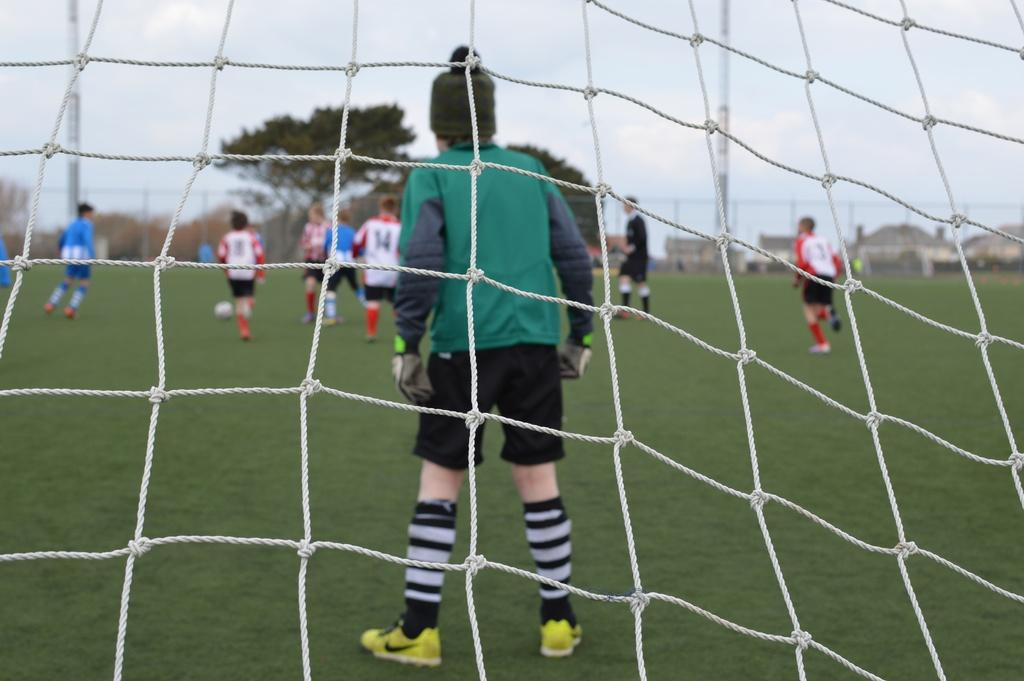<image>
Summarize the visual content of the image. A view of a goalie in soccer from behind the net with many numbered players such as 14 and 8 in the background. 